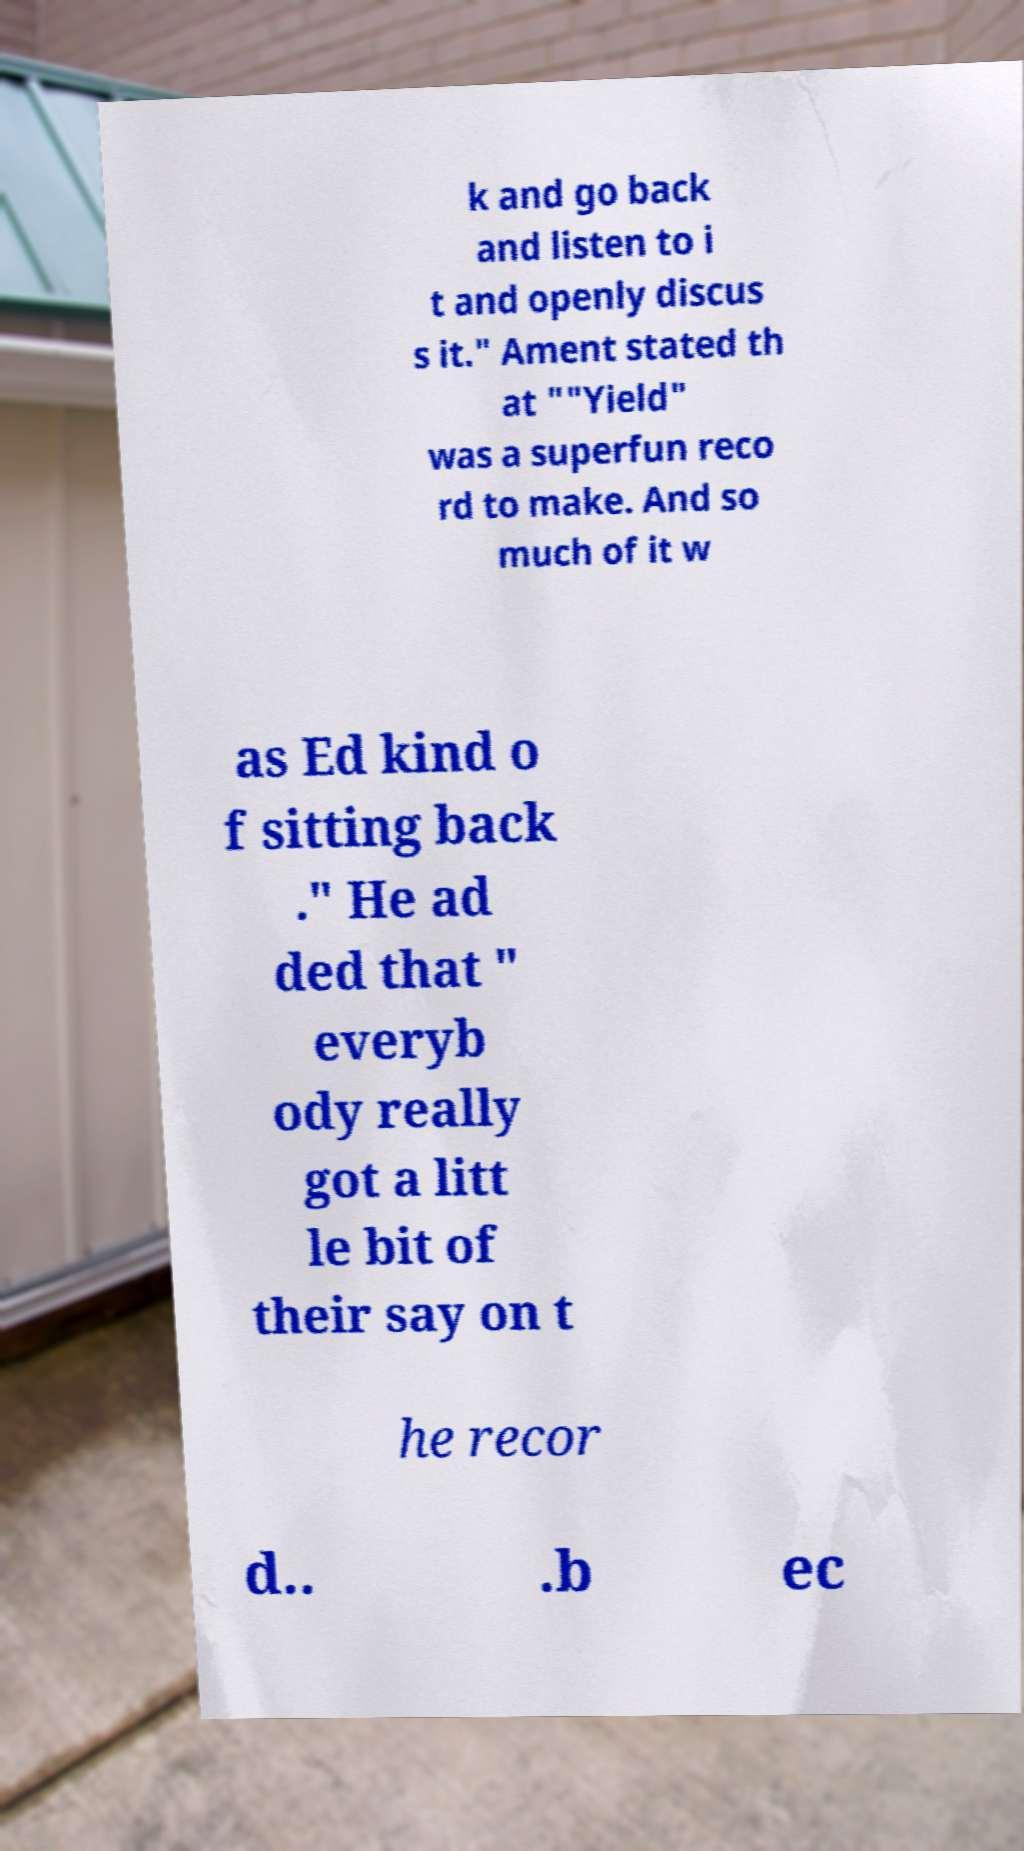There's text embedded in this image that I need extracted. Can you transcribe it verbatim? k and go back and listen to i t and openly discus s it." Ament stated th at ""Yield" was a superfun reco rd to make. And so much of it w as Ed kind o f sitting back ." He ad ded that " everyb ody really got a litt le bit of their say on t he recor d.. .b ec 